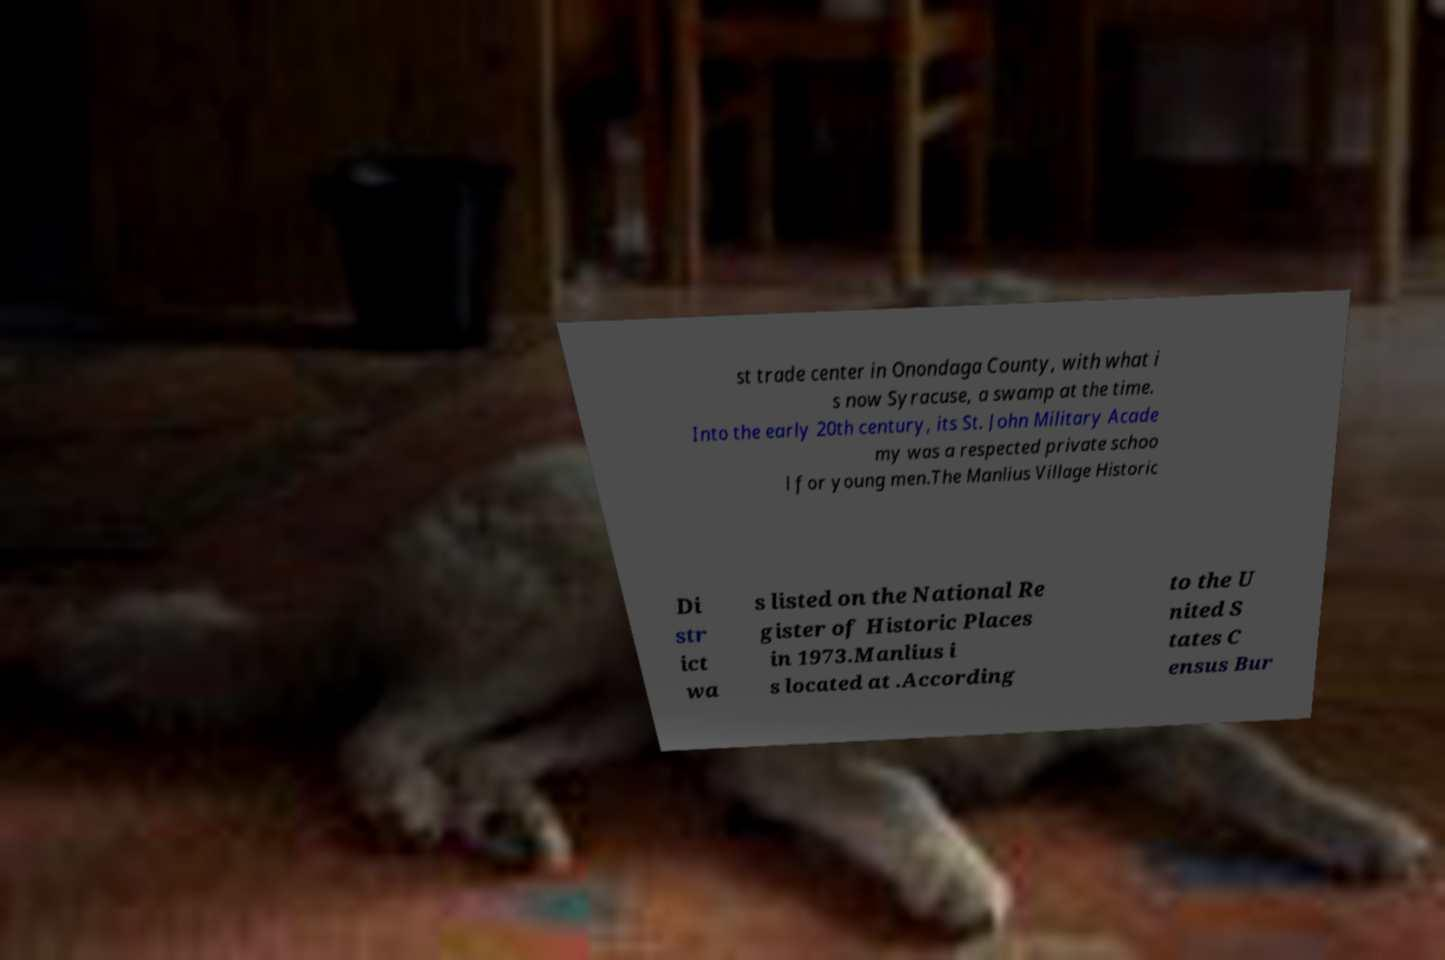For documentation purposes, I need the text within this image transcribed. Could you provide that? st trade center in Onondaga County, with what i s now Syracuse, a swamp at the time. Into the early 20th century, its St. John Military Acade my was a respected private schoo l for young men.The Manlius Village Historic Di str ict wa s listed on the National Re gister of Historic Places in 1973.Manlius i s located at .According to the U nited S tates C ensus Bur 